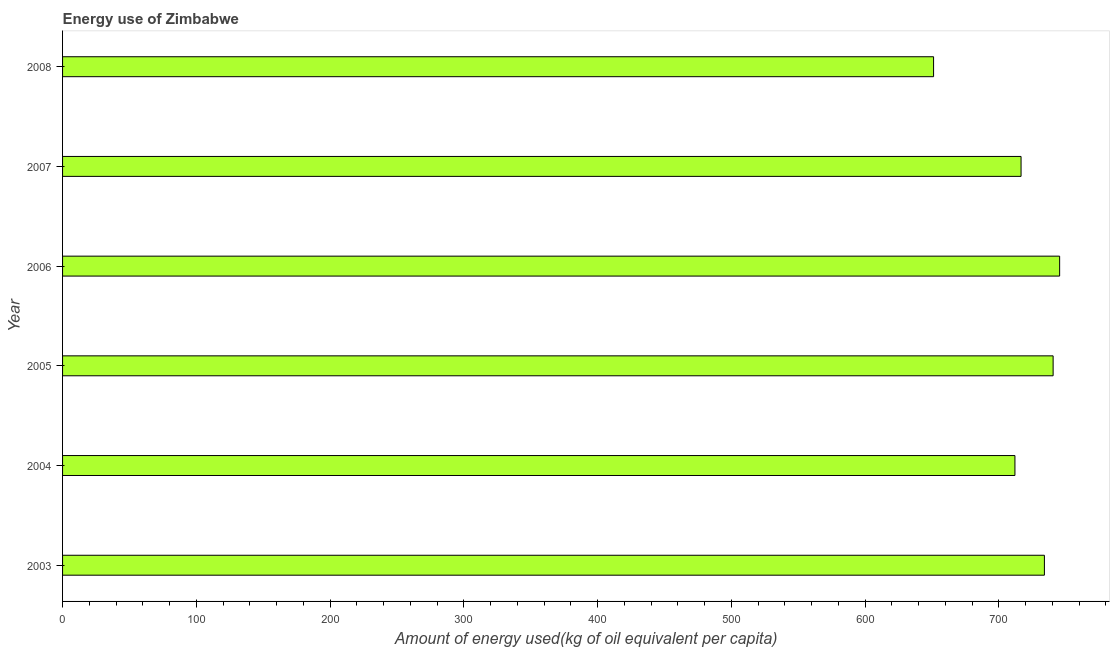Does the graph contain grids?
Your answer should be compact. No. What is the title of the graph?
Keep it short and to the point. Energy use of Zimbabwe. What is the label or title of the X-axis?
Offer a very short reply. Amount of energy used(kg of oil equivalent per capita). What is the amount of energy used in 2003?
Offer a terse response. 733.98. Across all years, what is the maximum amount of energy used?
Offer a very short reply. 745.36. Across all years, what is the minimum amount of energy used?
Ensure brevity in your answer.  651.13. What is the sum of the amount of energy used?
Ensure brevity in your answer.  4299.43. What is the difference between the amount of energy used in 2004 and 2008?
Provide a short and direct response. 60.82. What is the average amount of energy used per year?
Offer a terse response. 716.57. What is the median amount of energy used?
Your answer should be very brief. 725.25. What is the ratio of the amount of energy used in 2003 to that in 2004?
Make the answer very short. 1.03. What is the difference between the highest and the second highest amount of energy used?
Provide a short and direct response. 4.87. Is the sum of the amount of energy used in 2006 and 2008 greater than the maximum amount of energy used across all years?
Provide a short and direct response. Yes. What is the difference between the highest and the lowest amount of energy used?
Your answer should be very brief. 94.24. Are the values on the major ticks of X-axis written in scientific E-notation?
Provide a succinct answer. No. What is the Amount of energy used(kg of oil equivalent per capita) of 2003?
Offer a very short reply. 733.98. What is the Amount of energy used(kg of oil equivalent per capita) of 2004?
Provide a succinct answer. 711.94. What is the Amount of energy used(kg of oil equivalent per capita) in 2005?
Your response must be concise. 740.5. What is the Amount of energy used(kg of oil equivalent per capita) of 2006?
Provide a succinct answer. 745.36. What is the Amount of energy used(kg of oil equivalent per capita) in 2007?
Your response must be concise. 716.52. What is the Amount of energy used(kg of oil equivalent per capita) in 2008?
Keep it short and to the point. 651.13. What is the difference between the Amount of energy used(kg of oil equivalent per capita) in 2003 and 2004?
Your response must be concise. 22.03. What is the difference between the Amount of energy used(kg of oil equivalent per capita) in 2003 and 2005?
Your response must be concise. -6.52. What is the difference between the Amount of energy used(kg of oil equivalent per capita) in 2003 and 2006?
Your answer should be compact. -11.38. What is the difference between the Amount of energy used(kg of oil equivalent per capita) in 2003 and 2007?
Make the answer very short. 17.46. What is the difference between the Amount of energy used(kg of oil equivalent per capita) in 2003 and 2008?
Ensure brevity in your answer.  82.85. What is the difference between the Amount of energy used(kg of oil equivalent per capita) in 2004 and 2005?
Ensure brevity in your answer.  -28.55. What is the difference between the Amount of energy used(kg of oil equivalent per capita) in 2004 and 2006?
Provide a succinct answer. -33.42. What is the difference between the Amount of energy used(kg of oil equivalent per capita) in 2004 and 2007?
Give a very brief answer. -4.57. What is the difference between the Amount of energy used(kg of oil equivalent per capita) in 2004 and 2008?
Make the answer very short. 60.82. What is the difference between the Amount of energy used(kg of oil equivalent per capita) in 2005 and 2006?
Your response must be concise. -4.87. What is the difference between the Amount of energy used(kg of oil equivalent per capita) in 2005 and 2007?
Offer a terse response. 23.98. What is the difference between the Amount of energy used(kg of oil equivalent per capita) in 2005 and 2008?
Make the answer very short. 89.37. What is the difference between the Amount of energy used(kg of oil equivalent per capita) in 2006 and 2007?
Your response must be concise. 28.84. What is the difference between the Amount of energy used(kg of oil equivalent per capita) in 2006 and 2008?
Ensure brevity in your answer.  94.24. What is the difference between the Amount of energy used(kg of oil equivalent per capita) in 2007 and 2008?
Your answer should be compact. 65.39. What is the ratio of the Amount of energy used(kg of oil equivalent per capita) in 2003 to that in 2004?
Make the answer very short. 1.03. What is the ratio of the Amount of energy used(kg of oil equivalent per capita) in 2003 to that in 2006?
Make the answer very short. 0.98. What is the ratio of the Amount of energy used(kg of oil equivalent per capita) in 2003 to that in 2007?
Make the answer very short. 1.02. What is the ratio of the Amount of energy used(kg of oil equivalent per capita) in 2003 to that in 2008?
Your answer should be compact. 1.13. What is the ratio of the Amount of energy used(kg of oil equivalent per capita) in 2004 to that in 2005?
Provide a succinct answer. 0.96. What is the ratio of the Amount of energy used(kg of oil equivalent per capita) in 2004 to that in 2006?
Provide a short and direct response. 0.95. What is the ratio of the Amount of energy used(kg of oil equivalent per capita) in 2004 to that in 2007?
Your response must be concise. 0.99. What is the ratio of the Amount of energy used(kg of oil equivalent per capita) in 2004 to that in 2008?
Offer a very short reply. 1.09. What is the ratio of the Amount of energy used(kg of oil equivalent per capita) in 2005 to that in 2006?
Your response must be concise. 0.99. What is the ratio of the Amount of energy used(kg of oil equivalent per capita) in 2005 to that in 2007?
Make the answer very short. 1.03. What is the ratio of the Amount of energy used(kg of oil equivalent per capita) in 2005 to that in 2008?
Your answer should be compact. 1.14. What is the ratio of the Amount of energy used(kg of oil equivalent per capita) in 2006 to that in 2008?
Your answer should be very brief. 1.15. What is the ratio of the Amount of energy used(kg of oil equivalent per capita) in 2007 to that in 2008?
Ensure brevity in your answer.  1.1. 